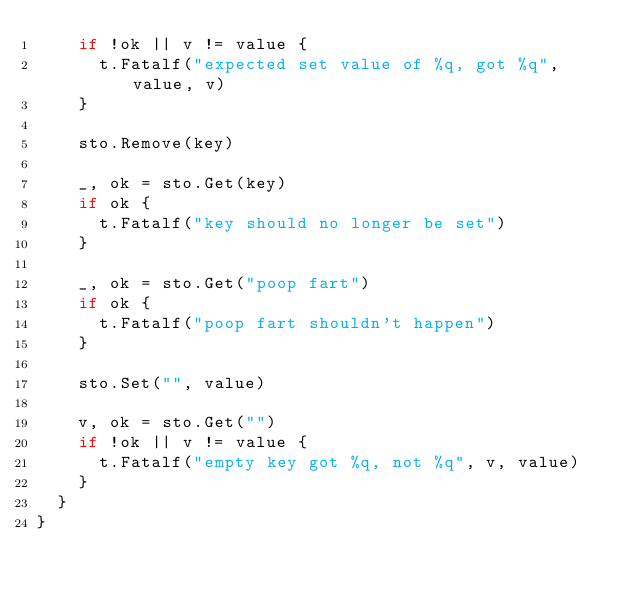<code> <loc_0><loc_0><loc_500><loc_500><_Go_>		if !ok || v != value {
			t.Fatalf("expected set value of %q, got %q", value, v)
		}

		sto.Remove(key)

		_, ok = sto.Get(key)
		if ok {
			t.Fatalf("key should no longer be set")
		}

		_, ok = sto.Get("poop fart")
		if ok {
			t.Fatalf("poop fart shouldn't happen")
		}

		sto.Set("", value)

		v, ok = sto.Get("")
		if !ok || v != value {
			t.Fatalf("empty key got %q, not %q", v, value)
		}
	}
}
</code> 